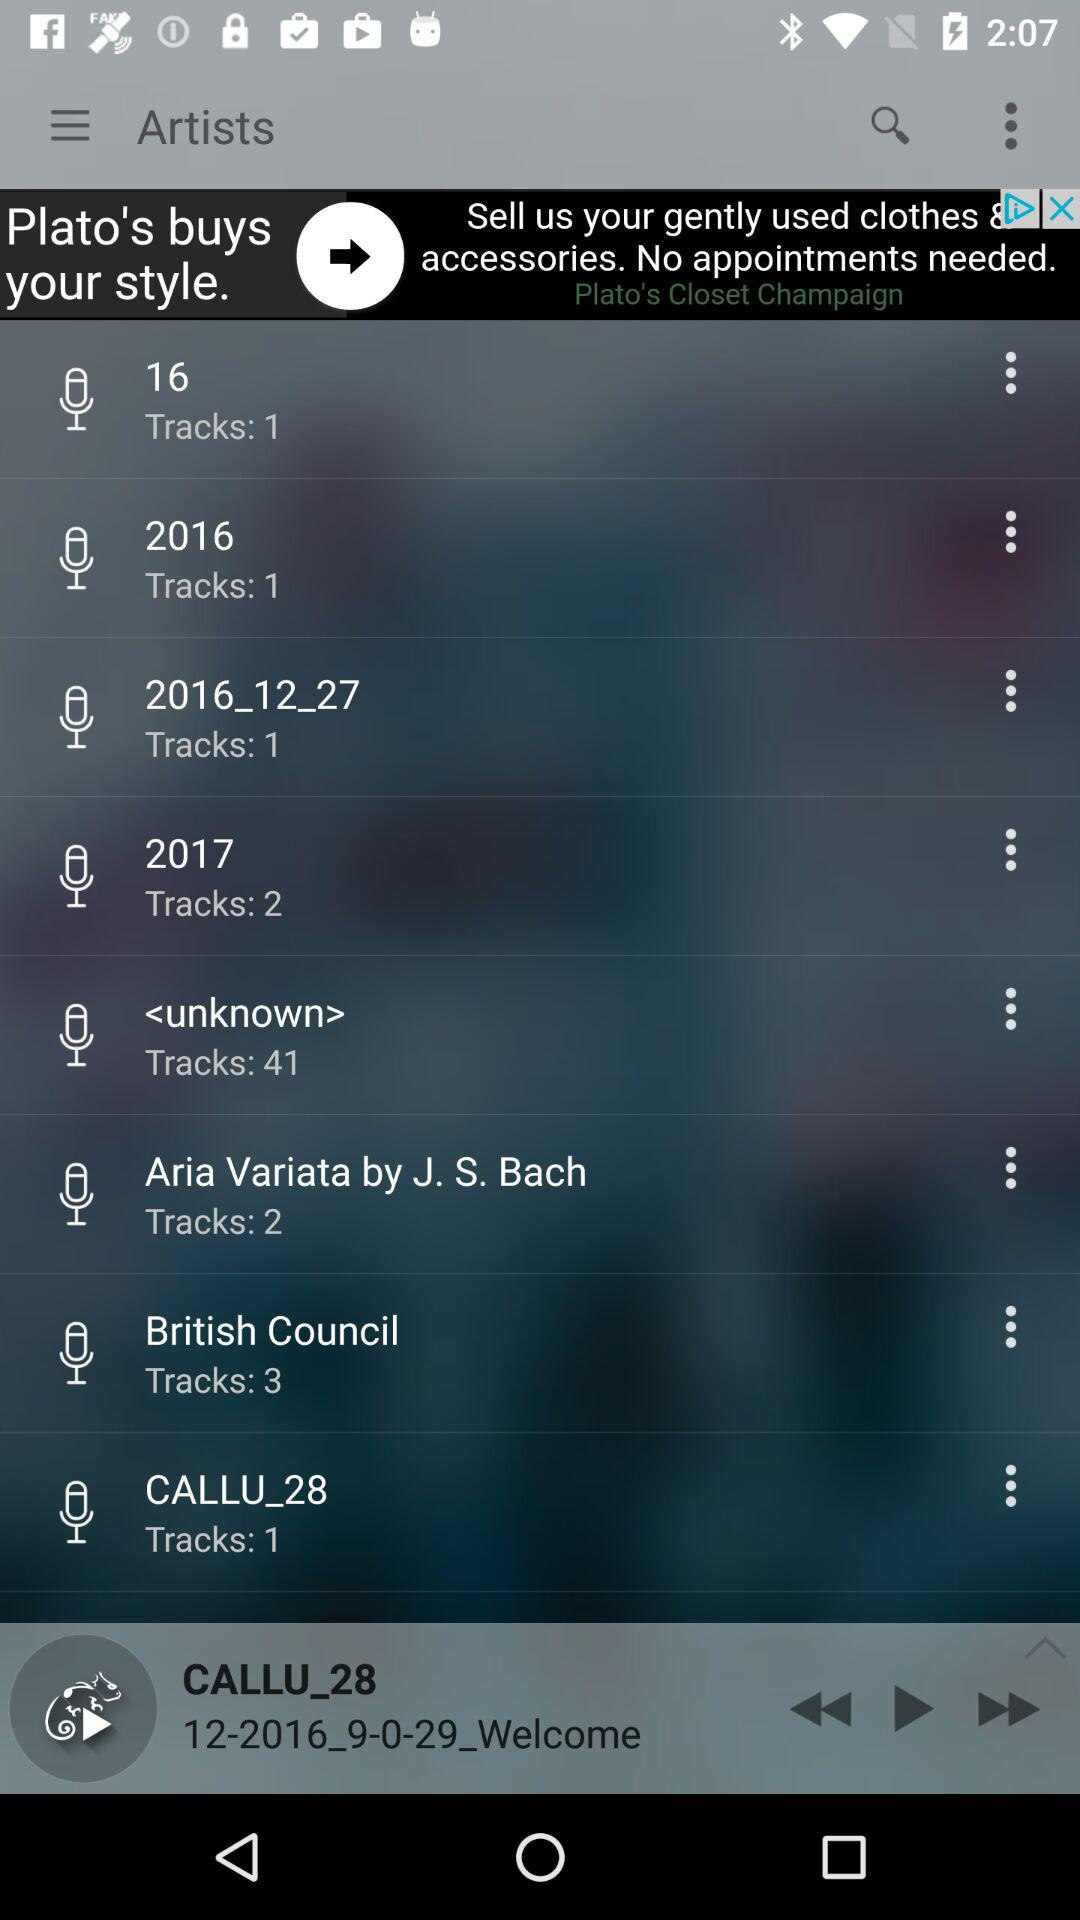Which song is paused? The paused song is "12-2016_9-0-29_Welcome". 